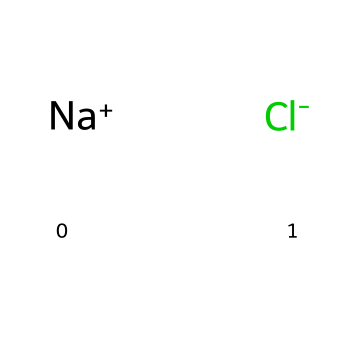What is the overall charge of sodium chloride? Sodium chloride consists of one sodium ion (Na+) and one chloride ion (Cl-). The positive charge on sodium (+1) and the negative charge on chloride (-1) balance each other out, resulting in an overall charge of zero.
Answer: zero How many ions are present in sodium chloride? The chemical structure shows one sodium ion (Na+) and one chloride ion (Cl-). Thus, there are two ions in total in the compound sodium chloride.
Answer: two What type of bond is present in sodium chloride? Sodium chloride forms an ionic bond, which occurs due to the electrostatic attraction between the positively charged sodium ion and the negatively charged chloride ion.
Answer: ionic bond Which element is represented by Na in the structure? The symbol Na represents the element sodium, which is a metallic element known for being an alkali metal in group one of the periodic table.
Answer: sodium What is the formula for sodium chloride? The SMILES representation can be directly translated to the chemical formula, which combines the one sodium and one chloride to give NaCl as the formula.
Answer: NaCl What type of electrolyte is sodium chloride? Sodium chloride is classified as a strong electrolyte because it completely dissociates into its ions when dissolved in water, allowing it to conduct electricity efficiently.
Answer: strong electrolyte What effect does sodium chloride have on water's boiling point? The dissociation of sodium chloride into ions contributes to colligative properties, specifically elevating the boiling point of water through the phenomenon known as boiling point elevation.
Answer: elevation 